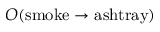<formula> <loc_0><loc_0><loc_500><loc_500>O ( s m o k e \rightarrow a s h t r a y )</formula> 